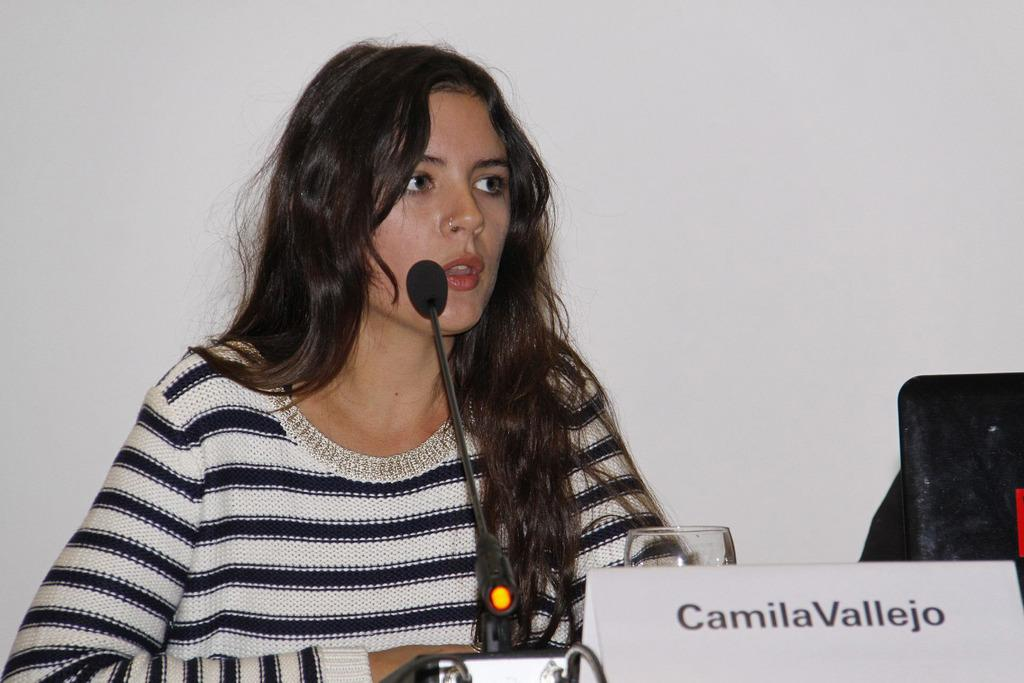What is the woman doing in the image? The woman is sitting at the desk in the image. What can be seen on the desk besides the woman? There is a glass tumbler and a name board on the desk. What is visible in the background of the image? There is a wall in the background of the image. What type of brick is used to construct the wall in the image? There is no information about the type of brick used to construct the wall in the image. 